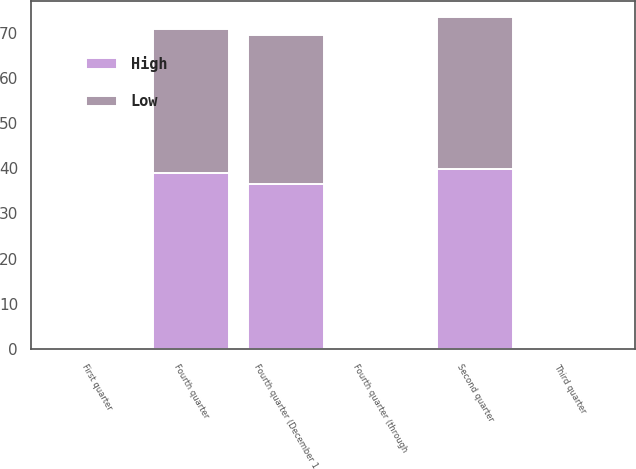Convert chart to OTSL. <chart><loc_0><loc_0><loc_500><loc_500><stacked_bar_chart><ecel><fcel>First quarter<fcel>Third quarter<fcel>Fourth quarter (through<fcel>Fourth quarter (December 1<fcel>Second quarter<fcel>Fourth quarter<nl><fcel>High<fcel>0.22<fcel>0.04<fcel>0.03<fcel>36.5<fcel>39.75<fcel>38.94<nl><fcel>Low<fcel>0.02<fcel>0.01<fcel>0.01<fcel>33<fcel>33.75<fcel>32<nl></chart> 